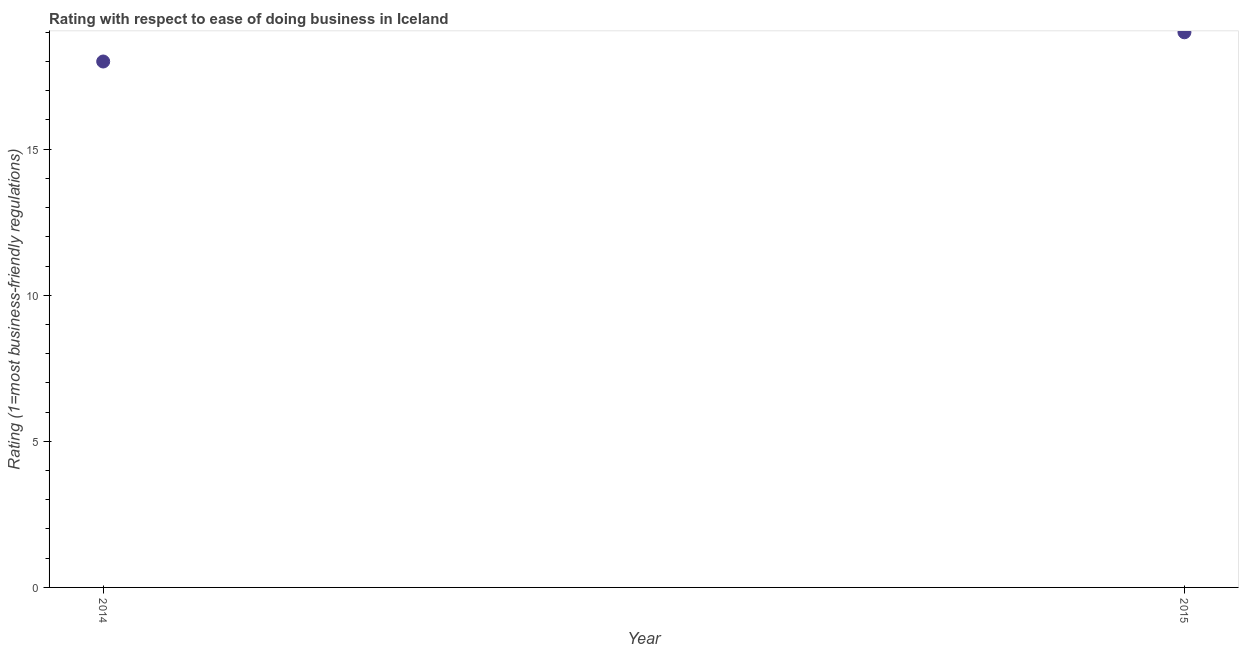What is the ease of doing business index in 2014?
Provide a short and direct response. 18. Across all years, what is the maximum ease of doing business index?
Make the answer very short. 19. Across all years, what is the minimum ease of doing business index?
Ensure brevity in your answer.  18. In which year was the ease of doing business index maximum?
Your response must be concise. 2015. In which year was the ease of doing business index minimum?
Keep it short and to the point. 2014. What is the sum of the ease of doing business index?
Give a very brief answer. 37. What is the difference between the ease of doing business index in 2014 and 2015?
Offer a terse response. -1. Do a majority of the years between 2015 and 2014 (inclusive) have ease of doing business index greater than 17 ?
Make the answer very short. No. What is the ratio of the ease of doing business index in 2014 to that in 2015?
Your answer should be very brief. 0.95. Is the ease of doing business index in 2014 less than that in 2015?
Provide a short and direct response. Yes. In how many years, is the ease of doing business index greater than the average ease of doing business index taken over all years?
Offer a very short reply. 1. How many dotlines are there?
Keep it short and to the point. 1. Does the graph contain grids?
Your answer should be very brief. No. What is the title of the graph?
Offer a terse response. Rating with respect to ease of doing business in Iceland. What is the label or title of the Y-axis?
Keep it short and to the point. Rating (1=most business-friendly regulations). What is the Rating (1=most business-friendly regulations) in 2015?
Keep it short and to the point. 19. What is the difference between the Rating (1=most business-friendly regulations) in 2014 and 2015?
Offer a very short reply. -1. What is the ratio of the Rating (1=most business-friendly regulations) in 2014 to that in 2015?
Provide a short and direct response. 0.95. 